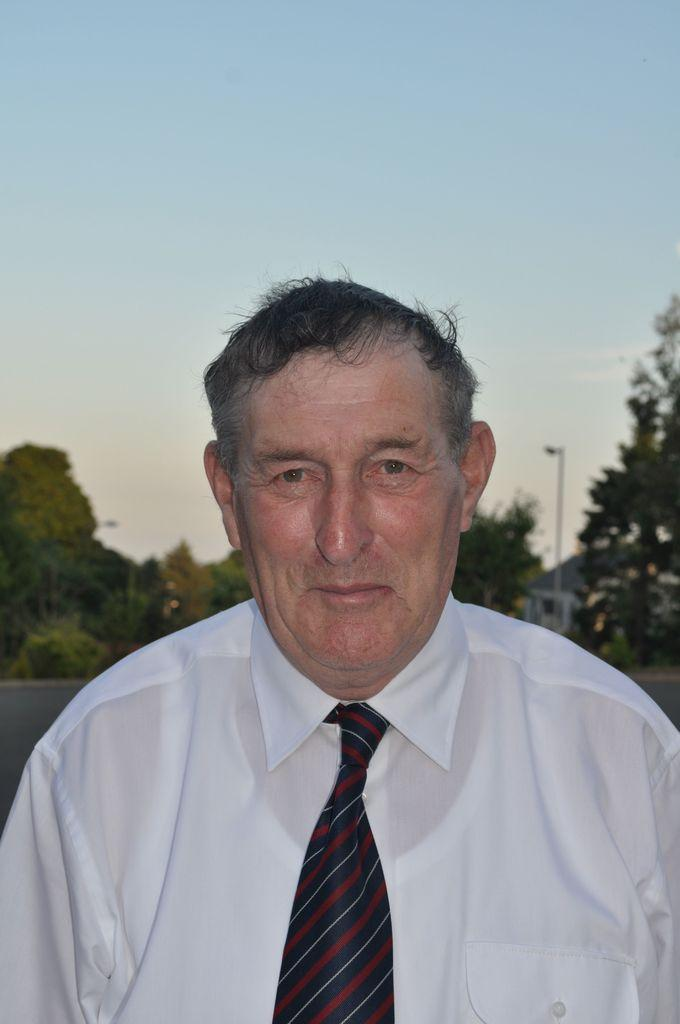Who is present in the image? There is a man in the image. What can be seen in the background of the image? There are trees, a street pole, a street light, a building, and the sky visible in the background of the image. How many insects can be seen flying around the man in the image? There are no insects visible in the image. What are the boys doing in the image? There are no boys present in the image. 